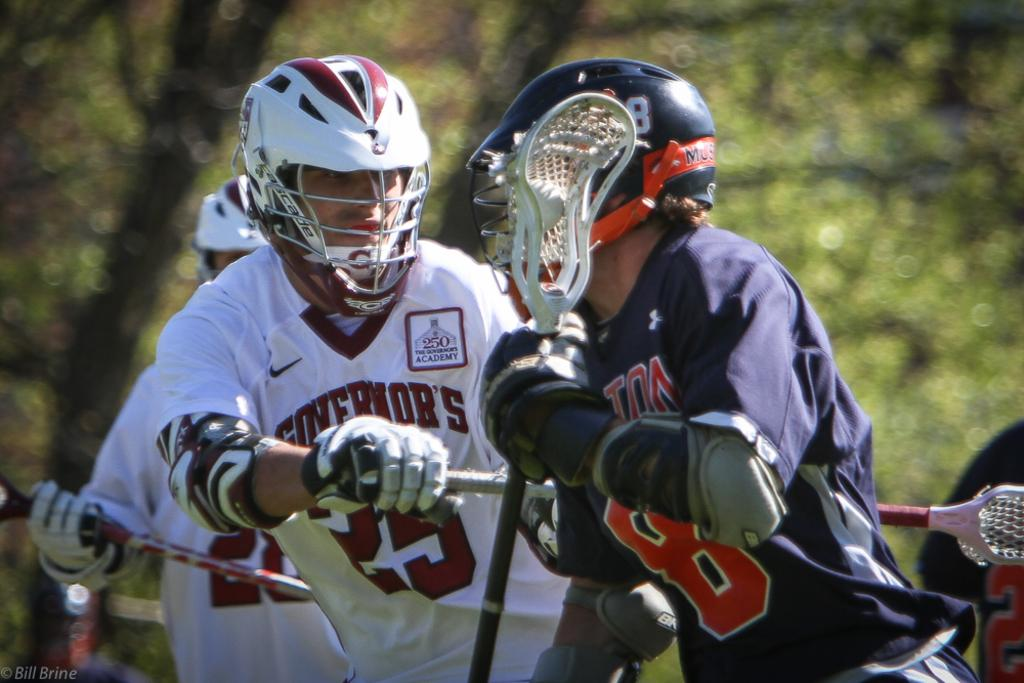How many people are in the image? There are people in the image, but the exact number is not specified. What are the people wearing on their heads? The people are wearing helmets. What are the people holding in their hands? The people are holding objects in their hands. What is the main area of interest in the image? The center of the image is the focus. How would you describe the background of the image? The background of the image is blurred. What type of division is taking place in the image? There is no division taking place in the image. Are there any trucks visible in the image? There is no mention of trucks in the image. 